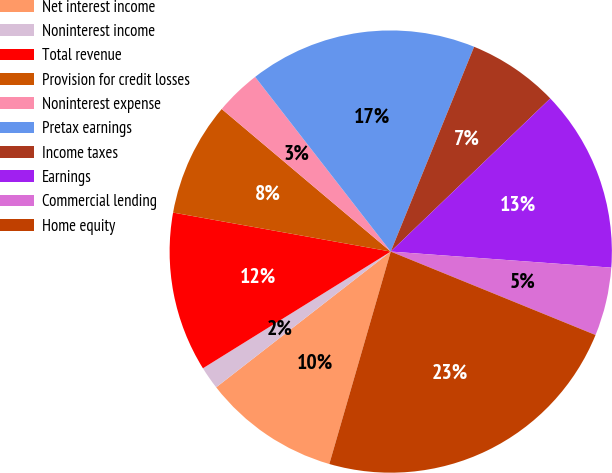<chart> <loc_0><loc_0><loc_500><loc_500><pie_chart><fcel>Net interest income<fcel>Noninterest income<fcel>Total revenue<fcel>Provision for credit losses<fcel>Noninterest expense<fcel>Pretax earnings<fcel>Income taxes<fcel>Earnings<fcel>Commercial lending<fcel>Home equity<nl><fcel>10.0%<fcel>1.67%<fcel>11.67%<fcel>8.33%<fcel>3.34%<fcel>16.66%<fcel>6.67%<fcel>13.33%<fcel>5.0%<fcel>23.32%<nl></chart> 